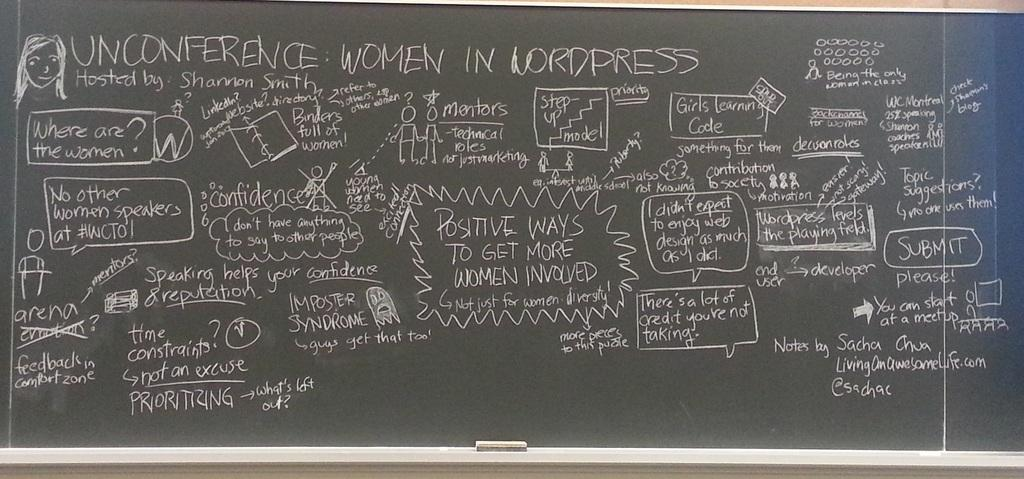Provide a one-sentence caption for the provided image. A chalkboard with many things written the biggest thing reads UNCONFERENCE IN LORDPRESS. 